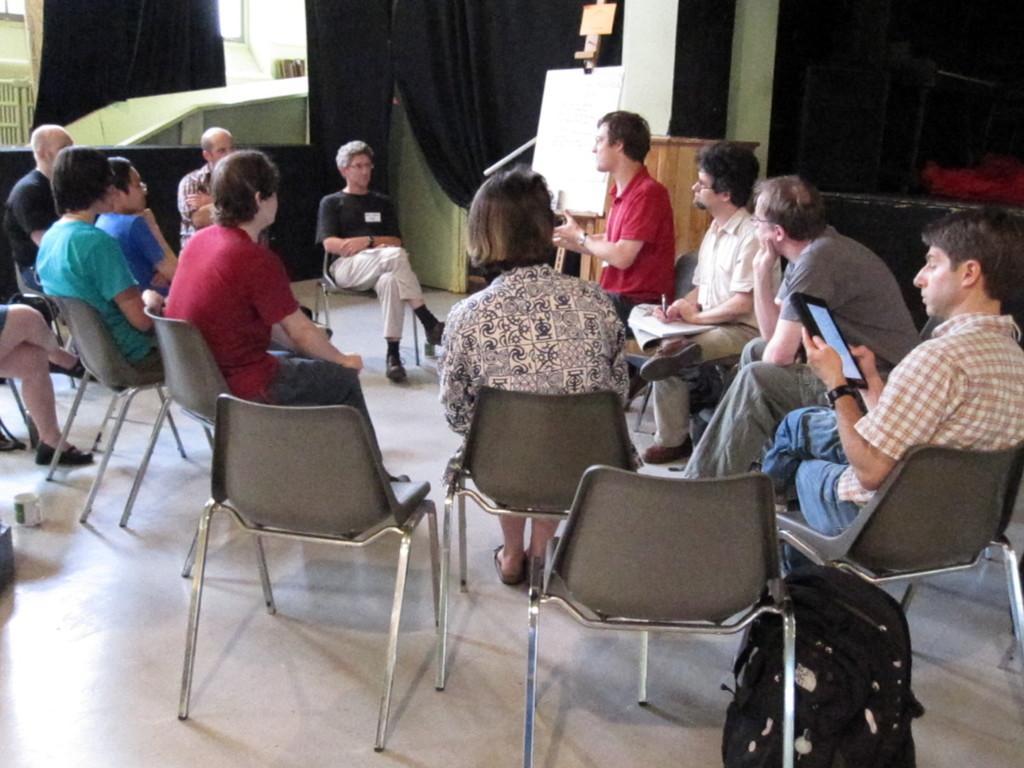Can you describe this image briefly? There are group of people sitting in the chairs. On the right side there is a person he is looking to the tablet he is wearing a watch ,on the side there is a bag and in the middle there is a person ,who is wearing a t shirt and a trouser on the bottom there is a cup. 